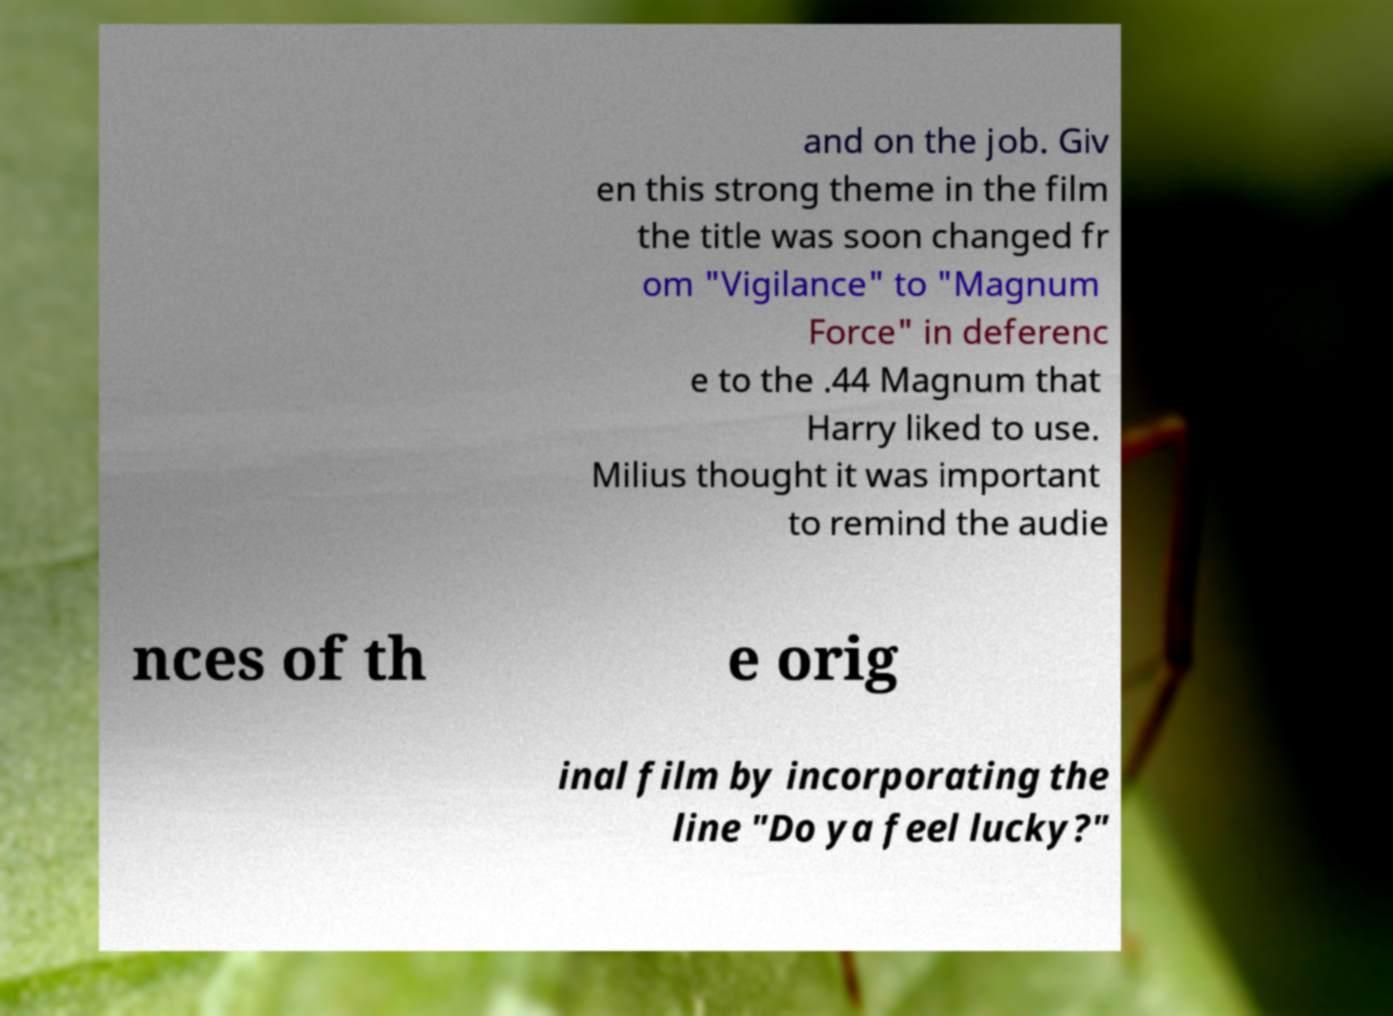Could you extract and type out the text from this image? and on the job. Giv en this strong theme in the film the title was soon changed fr om "Vigilance" to "Magnum Force" in deferenc e to the .44 Magnum that Harry liked to use. Milius thought it was important to remind the audie nces of th e orig inal film by incorporating the line "Do ya feel lucky?" 